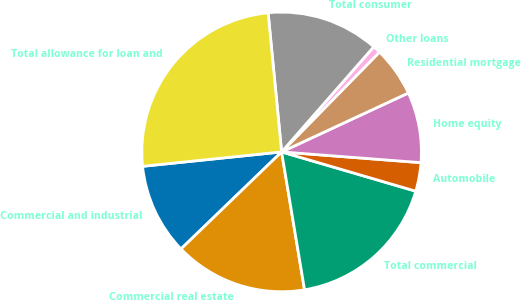<chart> <loc_0><loc_0><loc_500><loc_500><pie_chart><fcel>Commercial and industrial<fcel>Commercial real estate<fcel>Total commercial<fcel>Automobile<fcel>Home equity<fcel>Residential mortgage<fcel>Other loans<fcel>Total consumer<fcel>Total allowance for loan and<nl><fcel>10.57%<fcel>15.41%<fcel>17.84%<fcel>3.31%<fcel>8.15%<fcel>5.73%<fcel>0.89%<fcel>12.99%<fcel>25.1%<nl></chart> 